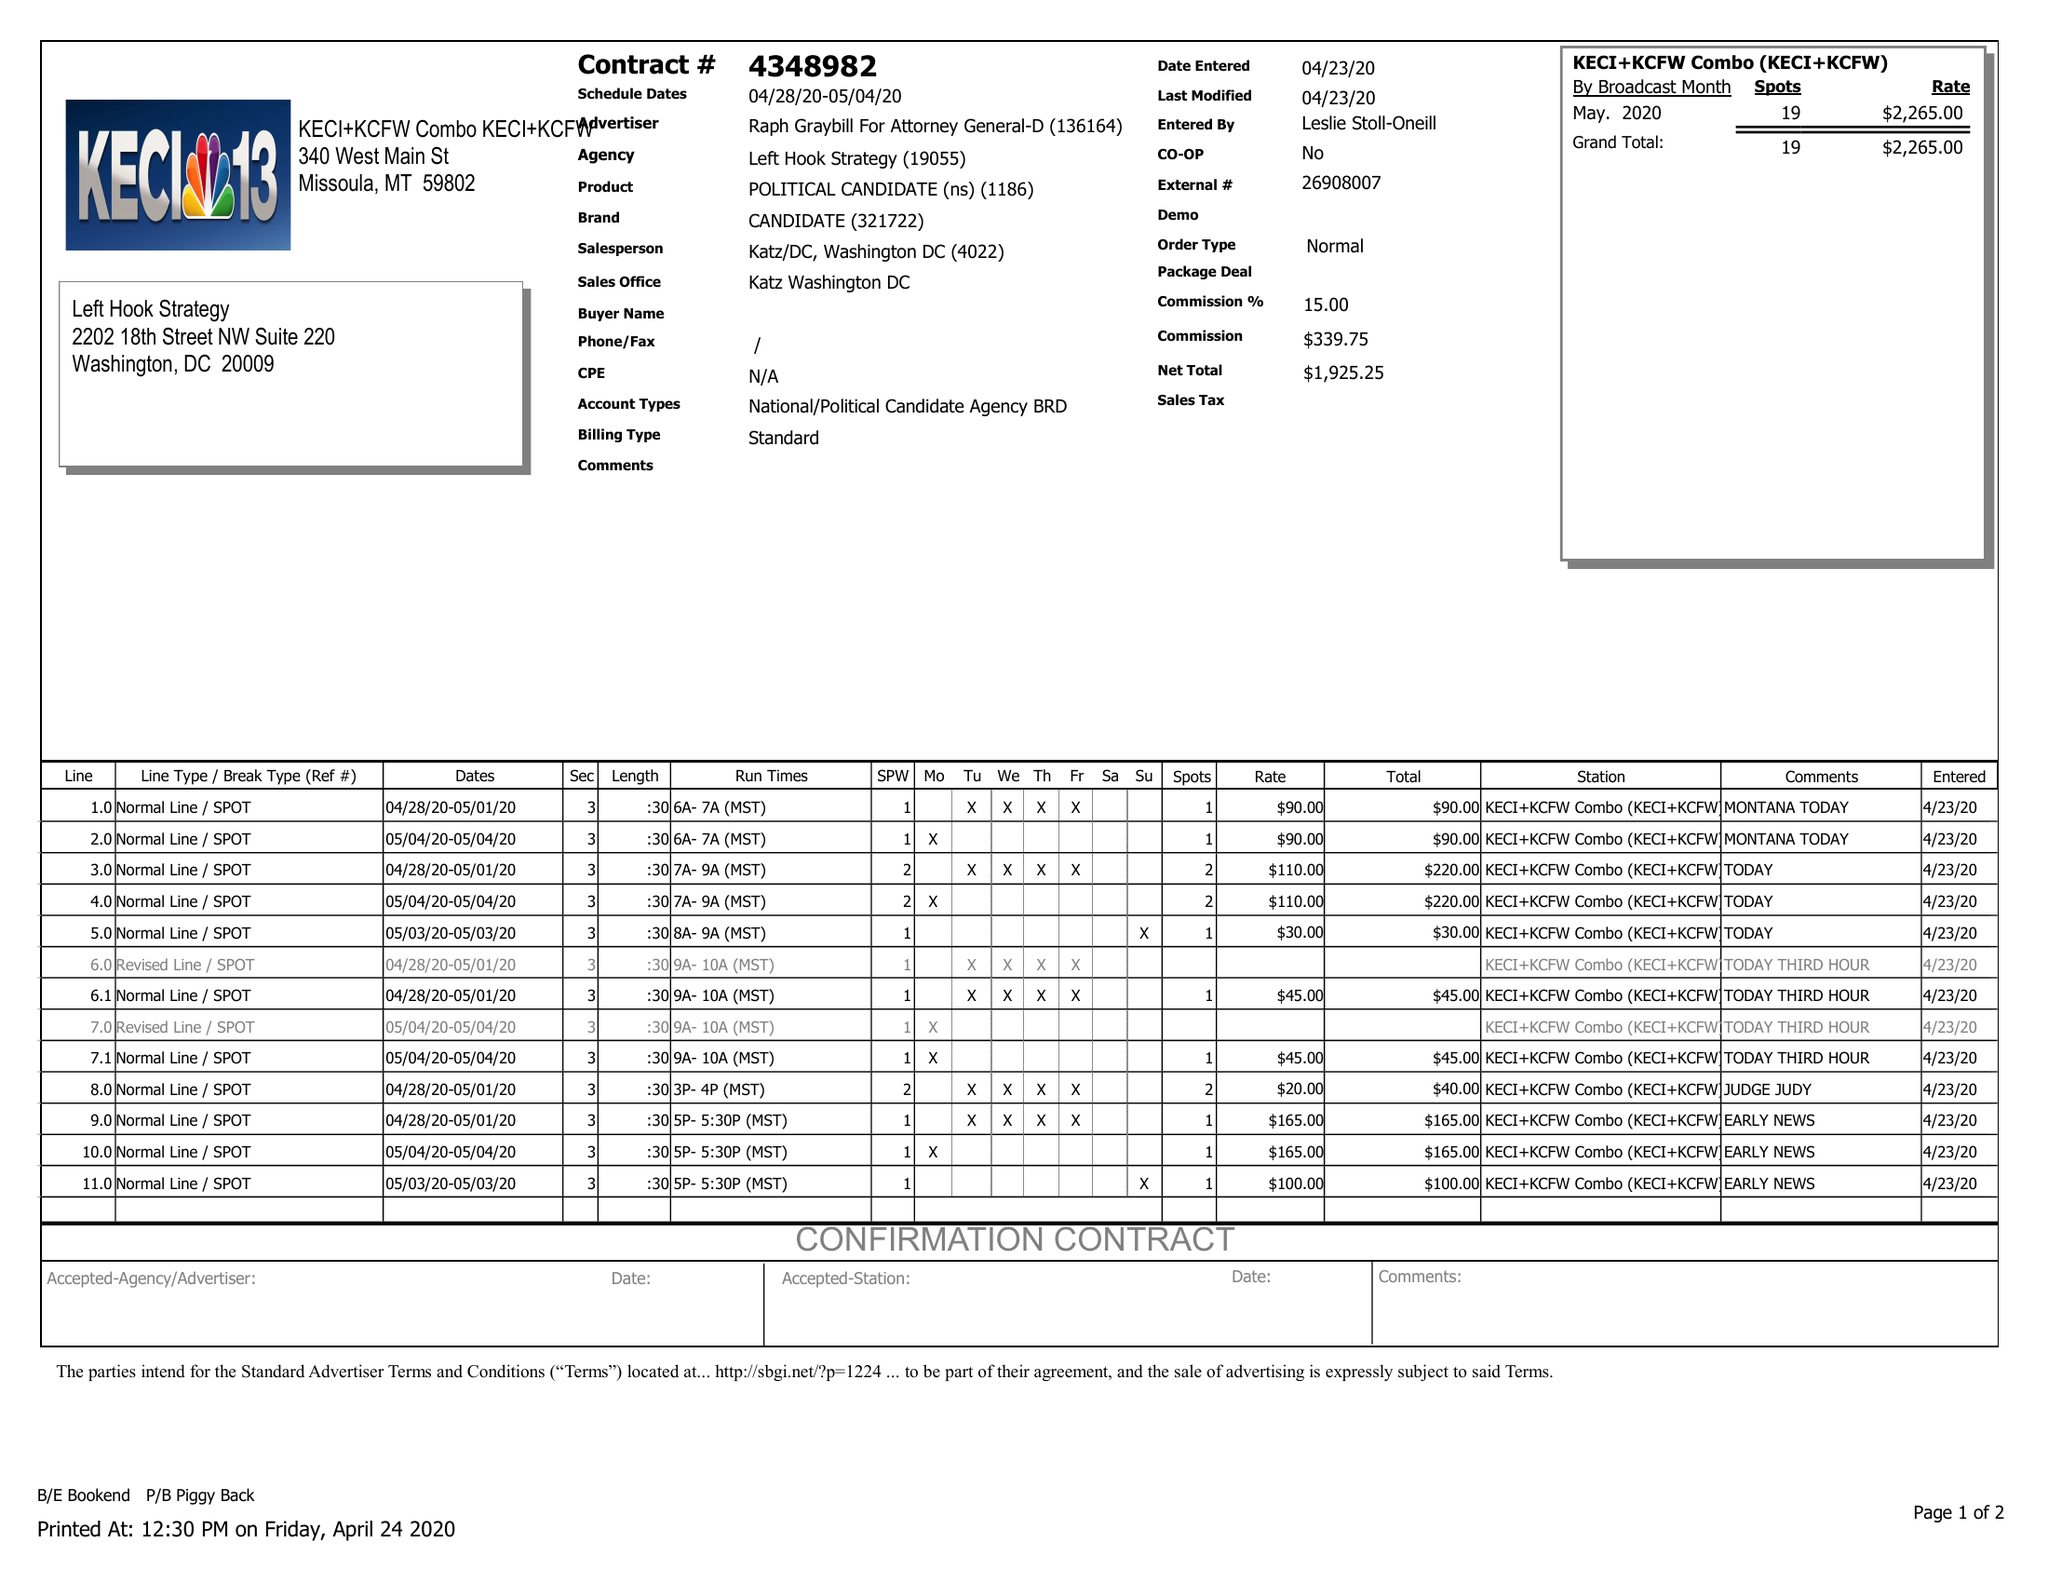What is the value for the flight_from?
Answer the question using a single word or phrase. 04/28/20 